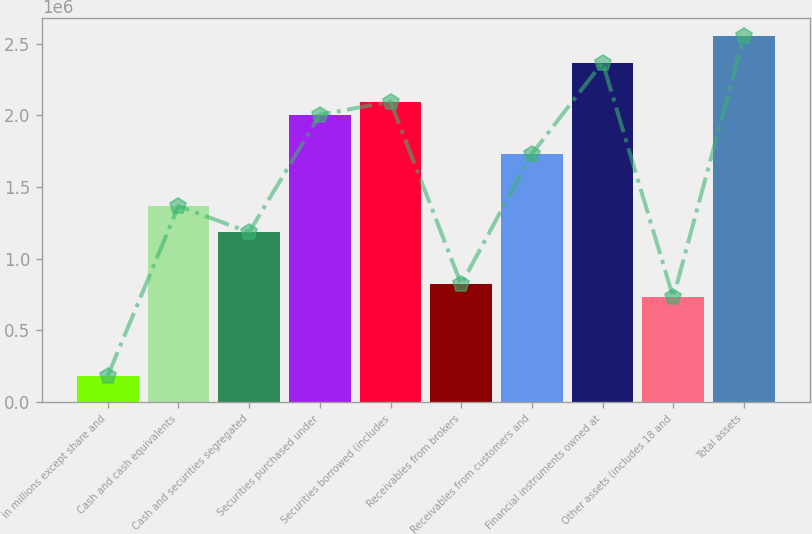Convert chart. <chart><loc_0><loc_0><loc_500><loc_500><bar_chart><fcel>in millions except share and<fcel>Cash and cash equivalents<fcel>Cash and securities segregated<fcel>Securities purchased under<fcel>Securities borrowed (includes<fcel>Receivables from brokers<fcel>Receivables from customers and<fcel>Financial instruments owned at<fcel>Other assets (includes 18 and<fcel>Total assets<nl><fcel>182308<fcel>1.36726e+06<fcel>1.18496e+06<fcel>2.00531e+06<fcel>2.09646e+06<fcel>820357<fcel>1.73186e+06<fcel>2.36991e+06<fcel>729207<fcel>2.55221e+06<nl></chart> 